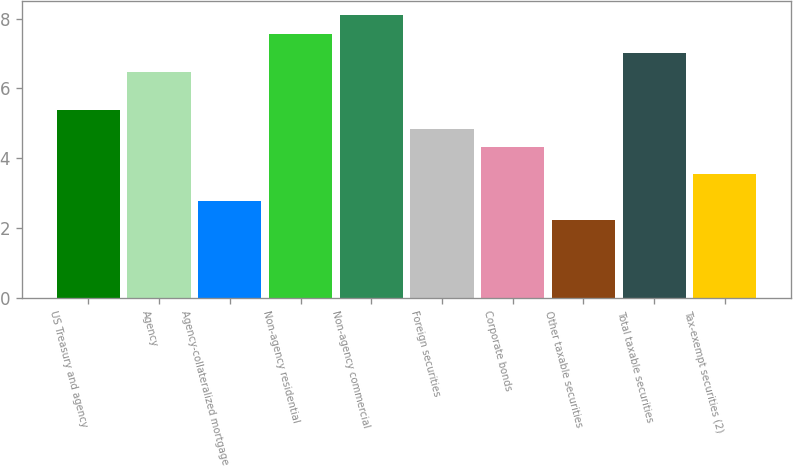Convert chart to OTSL. <chart><loc_0><loc_0><loc_500><loc_500><bar_chart><fcel>US Treasury and agency<fcel>Agency<fcel>Agency-collateralized mortgage<fcel>Non-agency residential<fcel>Non-agency commercial<fcel>Foreign securities<fcel>Corporate bonds<fcel>Other taxable securities<fcel>Total taxable securities<fcel>Tax-exempt securities (2)<nl><fcel>5.39<fcel>6.47<fcel>2.78<fcel>7.55<fcel>8.09<fcel>4.85<fcel>4.31<fcel>2.24<fcel>7.01<fcel>3.56<nl></chart> 